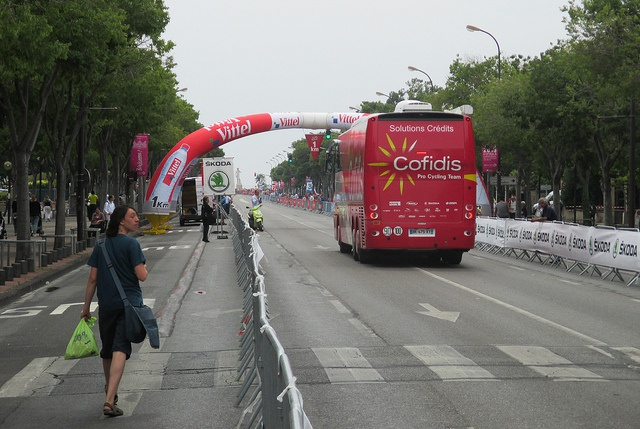Describe the objects in this image and their specific colors. I can see bus in darkgreen, brown, maroon, and black tones, truck in darkgreen, brown, maroon, and black tones, people in darkgreen, black, gray, and brown tones, backpack in darkgreen, black, darkblue, and purple tones, and handbag in darkgreen, black, darkblue, and purple tones in this image. 